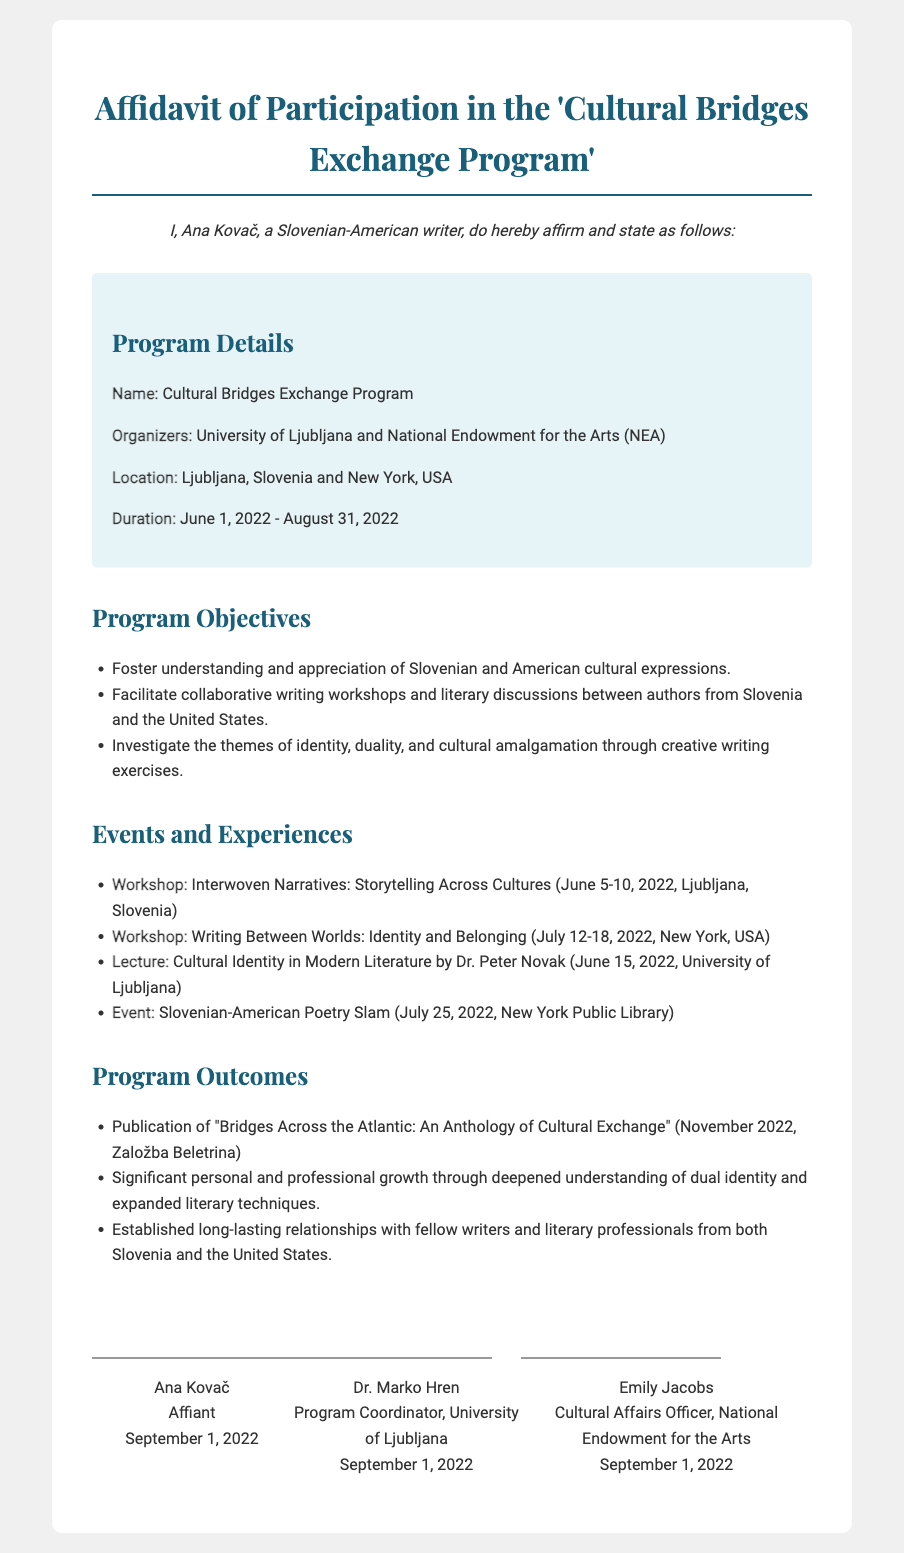What is the name of the program? The name of the program is explicitly mentioned in the document.
Answer: Cultural Bridges Exchange Program Who are the organizers of the program? The document lists both organizations that organized the program.
Answer: University of Ljubljana and National Endowment for the Arts What is the duration of the program? The document specifies the start and end dates of the program.
Answer: June 1, 2022 - August 31, 2022 What event took place in New York on July 25, 2022? The document identifies specific events with corresponding dates and locations.
Answer: Slovenian-American Poetry Slam How many workshops were conducted during the program? The document lists the workshops under events, requiring counting.
Answer: 2 What was one of the program's objectives related to identity? The document contains specific objectives stating the focus of cultural investigations.
Answer: Investigate the themes of identity, duality, and cultural amalgamation When was the anthology "Bridges Across the Atlantic" published? The publication date of the anthology is presented in the outcomes section of the document.
Answer: November 2022 Who signed the affidavit as the Program Coordinator? The document provides the names and titles of the signatories, including their roles.
Answer: Dr. Marko Hren What was the focus of the lecture delivered by Dr. Peter Novak? The document mentions the topic of the lecture clearly.
Answer: Cultural Identity in Modern Literature 